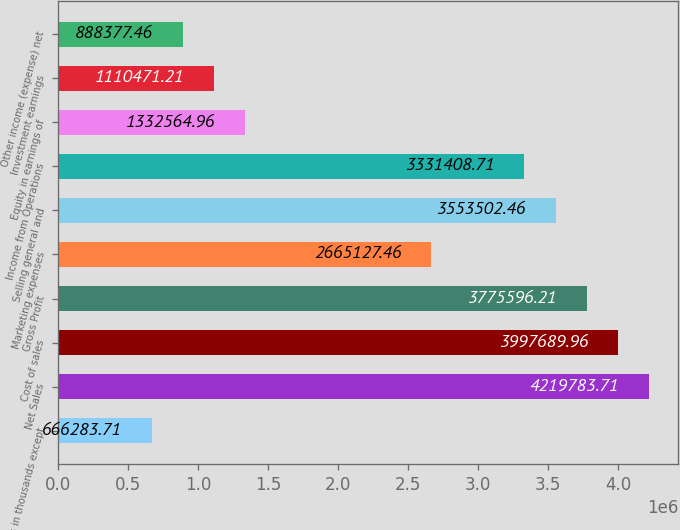<chart> <loc_0><loc_0><loc_500><loc_500><bar_chart><fcel>(Dollars in thousands except<fcel>Net Sales<fcel>Cost of sales<fcel>Gross Profit<fcel>Marketing expenses<fcel>Selling general and<fcel>Income from Operations<fcel>Equity in earnings of<fcel>Investment earnings<fcel>Other income (expense) net<nl><fcel>666284<fcel>4.21978e+06<fcel>3.99769e+06<fcel>3.7756e+06<fcel>2.66513e+06<fcel>3.5535e+06<fcel>3.33141e+06<fcel>1.33256e+06<fcel>1.11047e+06<fcel>888377<nl></chart> 